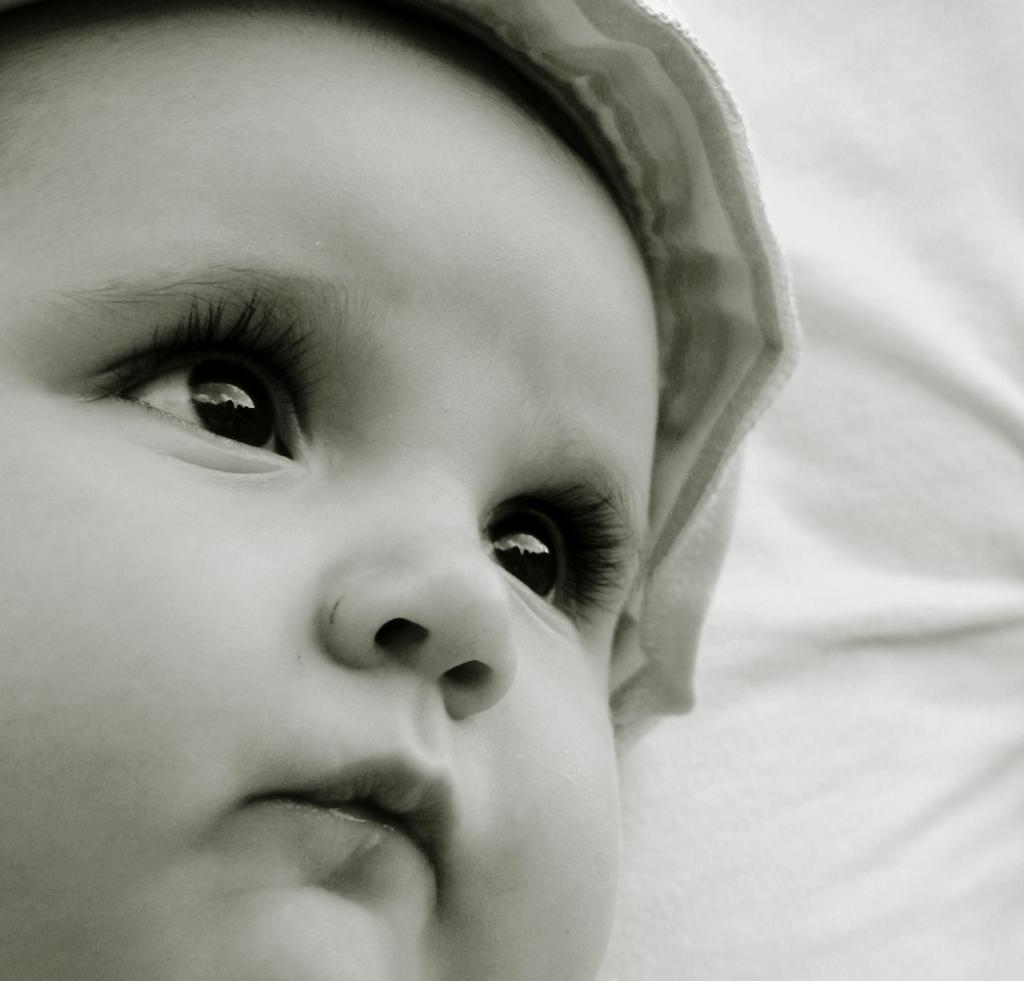What is the color scheme of the image? The image is black and white. What can be seen in the image? There is a baby's face visible in the image. What is the baby wearing on their head? The baby is wearing a cap. What else is present in the image besides the baby? There is a cloth beside the baby. What type of vest is the person wearing in the image? There is no person present in the image, and therefore no vest can be observed. Can you tell me if the baby has received approval for their actions in the image? The image does not depict any actions or convey any information about approval or disapproval. 